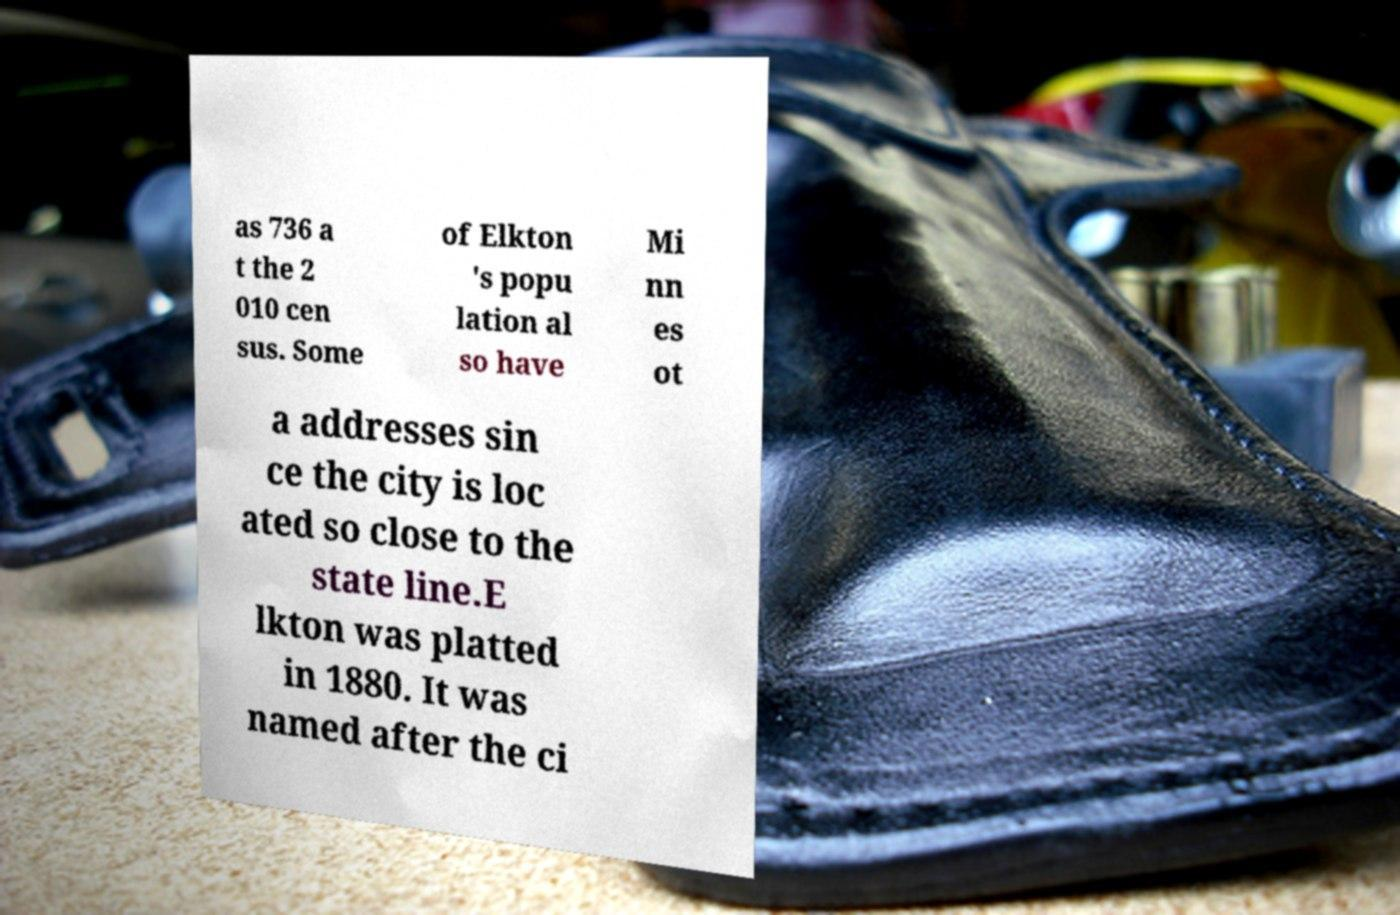Can you accurately transcribe the text from the provided image for me? as 736 a t the 2 010 cen sus. Some of Elkton 's popu lation al so have Mi nn es ot a addresses sin ce the city is loc ated so close to the state line.E lkton was platted in 1880. It was named after the ci 